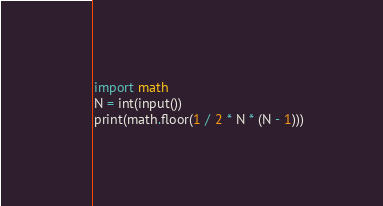Convert code to text. <code><loc_0><loc_0><loc_500><loc_500><_Python_>import math
N = int(input())
print(math.floor(1 / 2 * N * (N - 1)))
</code> 